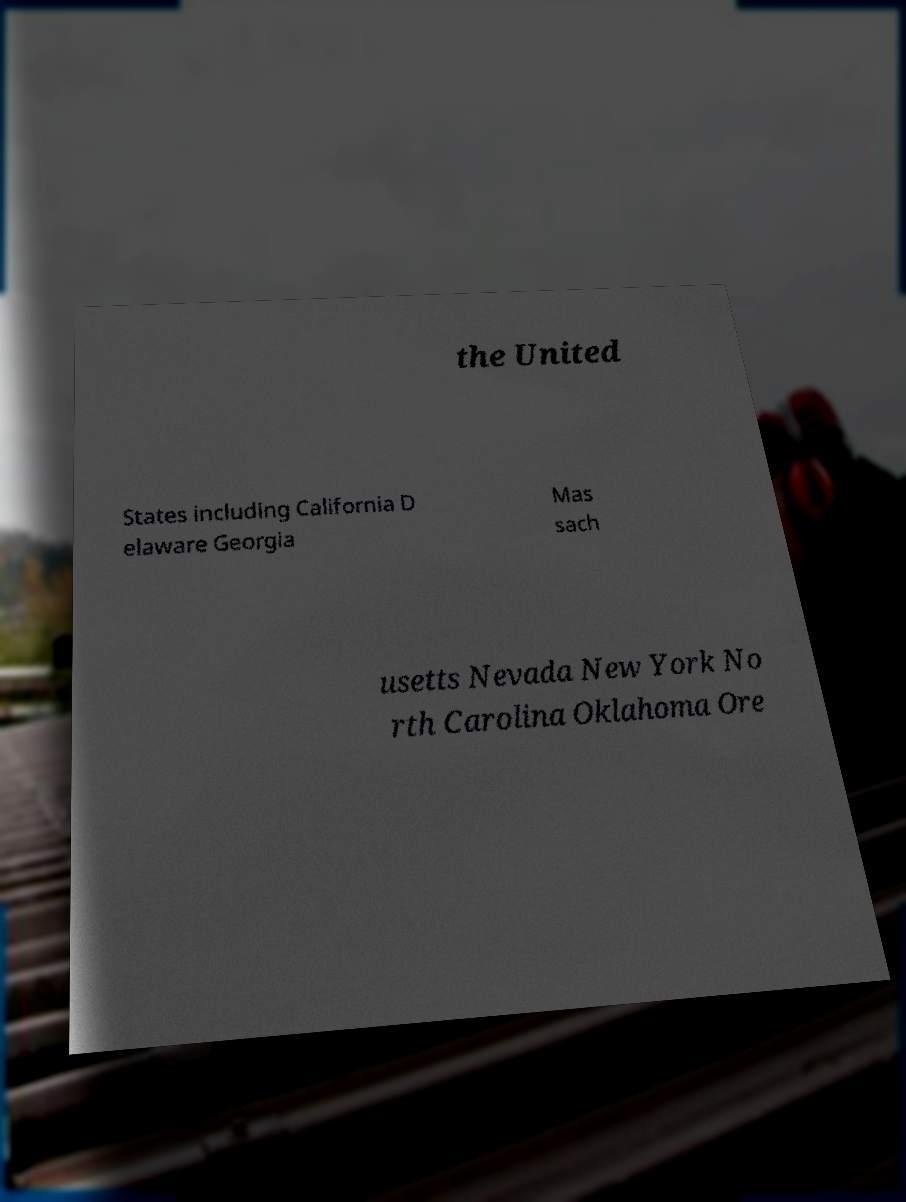Can you read and provide the text displayed in the image?This photo seems to have some interesting text. Can you extract and type it out for me? the United States including California D elaware Georgia Mas sach usetts Nevada New York No rth Carolina Oklahoma Ore 